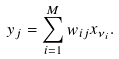<formula> <loc_0><loc_0><loc_500><loc_500>y _ { j } = \sum _ { i = 1 } ^ { M } w _ { i j } x _ { \nu _ { i } } . \\</formula> 